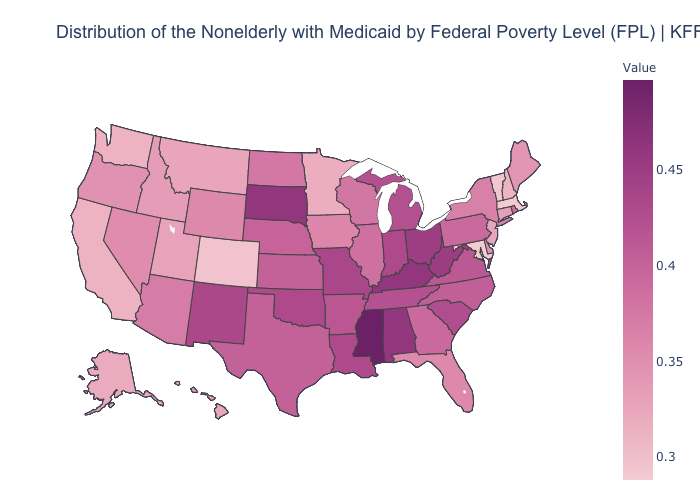Which states have the lowest value in the South?
Give a very brief answer. Maryland. Is the legend a continuous bar?
Quick response, please. Yes. Does the map have missing data?
Short answer required. No. Is the legend a continuous bar?
Be succinct. Yes. Does Iowa have a higher value than Massachusetts?
Short answer required. Yes. Does the map have missing data?
Concise answer only. No. 